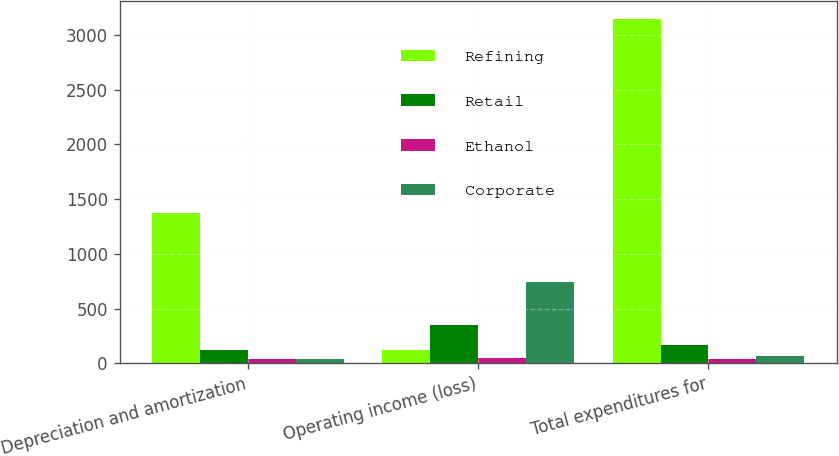<chart> <loc_0><loc_0><loc_500><loc_500><stacked_bar_chart><ecel><fcel>Depreciation and amortization<fcel>Operating income (loss)<fcel>Total expenditures for<nl><fcel>Refining<fcel>1370<fcel>119<fcel>3147<nl><fcel>Retail<fcel>119<fcel>348<fcel>164<nl><fcel>Ethanol<fcel>42<fcel>47<fcel>36<nl><fcel>Corporate<fcel>43<fcel>741<fcel>66<nl></chart> 